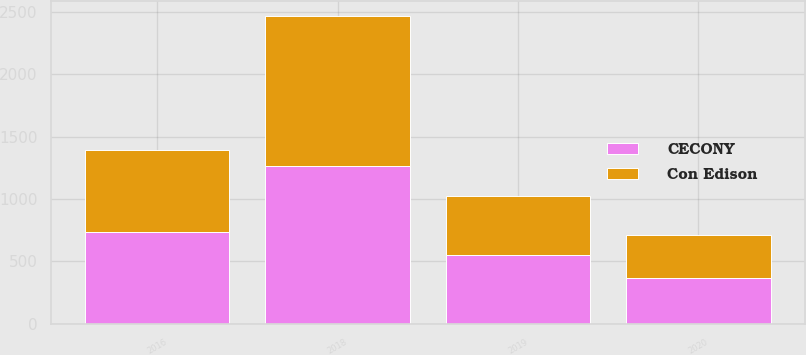Convert chart to OTSL. <chart><loc_0><loc_0><loc_500><loc_500><stacked_bar_chart><ecel><fcel>2016<fcel>2018<fcel>2019<fcel>2020<nl><fcel>CECONY<fcel>739<fcel>1266<fcel>552<fcel>365<nl><fcel>Con Edison<fcel>650<fcel>1200<fcel>475<fcel>350<nl></chart> 